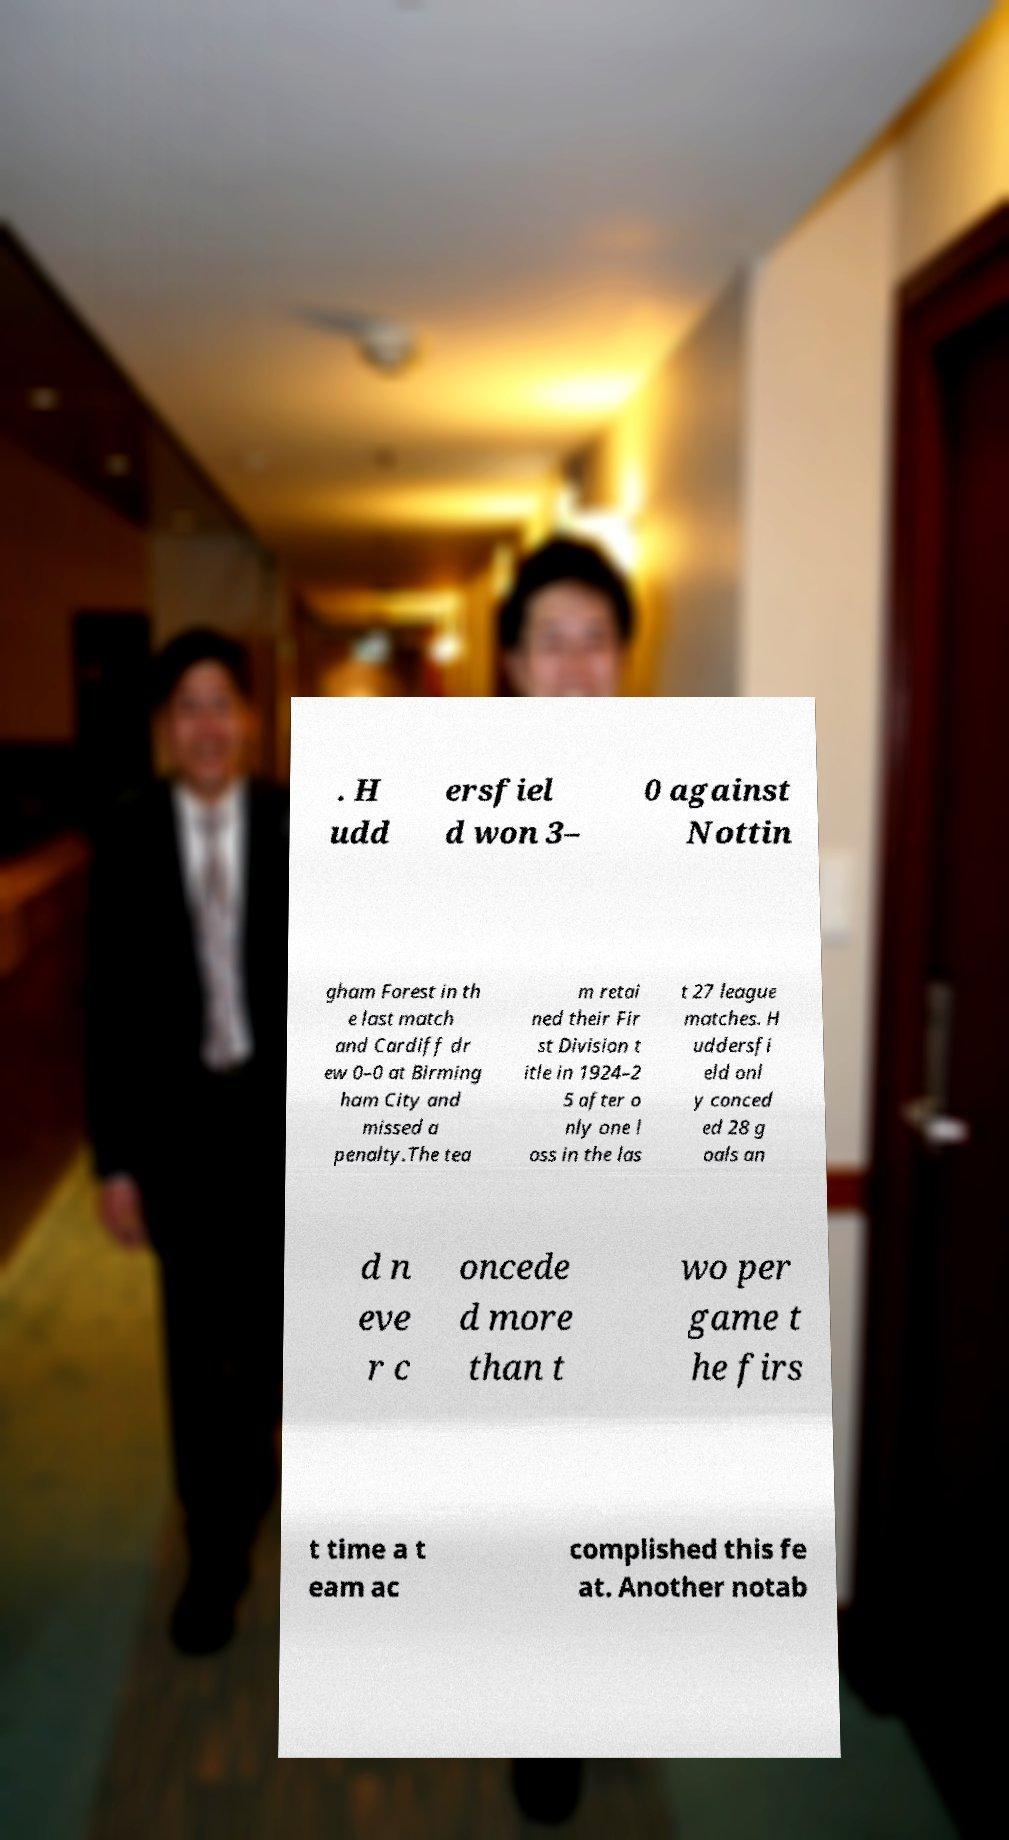There's text embedded in this image that I need extracted. Can you transcribe it verbatim? . H udd ersfiel d won 3– 0 against Nottin gham Forest in th e last match and Cardiff dr ew 0–0 at Birming ham City and missed a penalty.The tea m retai ned their Fir st Division t itle in 1924–2 5 after o nly one l oss in the las t 27 league matches. H uddersfi eld onl y conced ed 28 g oals an d n eve r c oncede d more than t wo per game t he firs t time a t eam ac complished this fe at. Another notab 